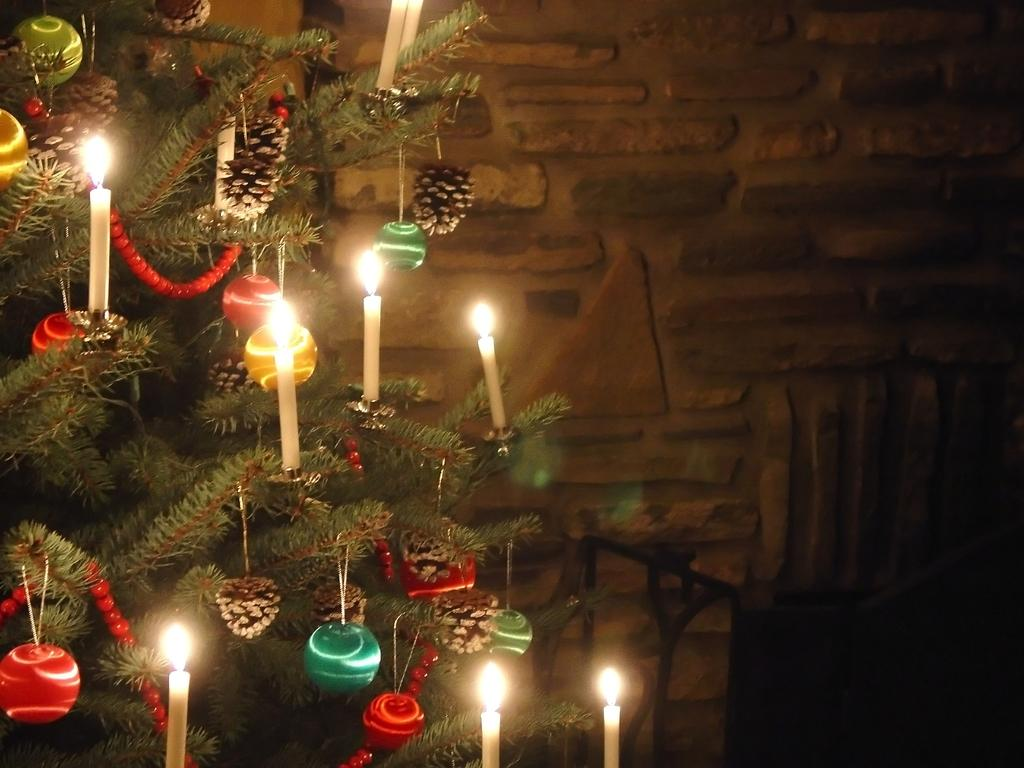What is located on the left side of the image? There is a Christmas tree on the left side of the image. What decorations are on the Christmas tree? The Christmas tree has candles. What can be seen in the background of the image? There is a wall in the background of the image. Where is the swing located in the image? There is no swing present in the image. 